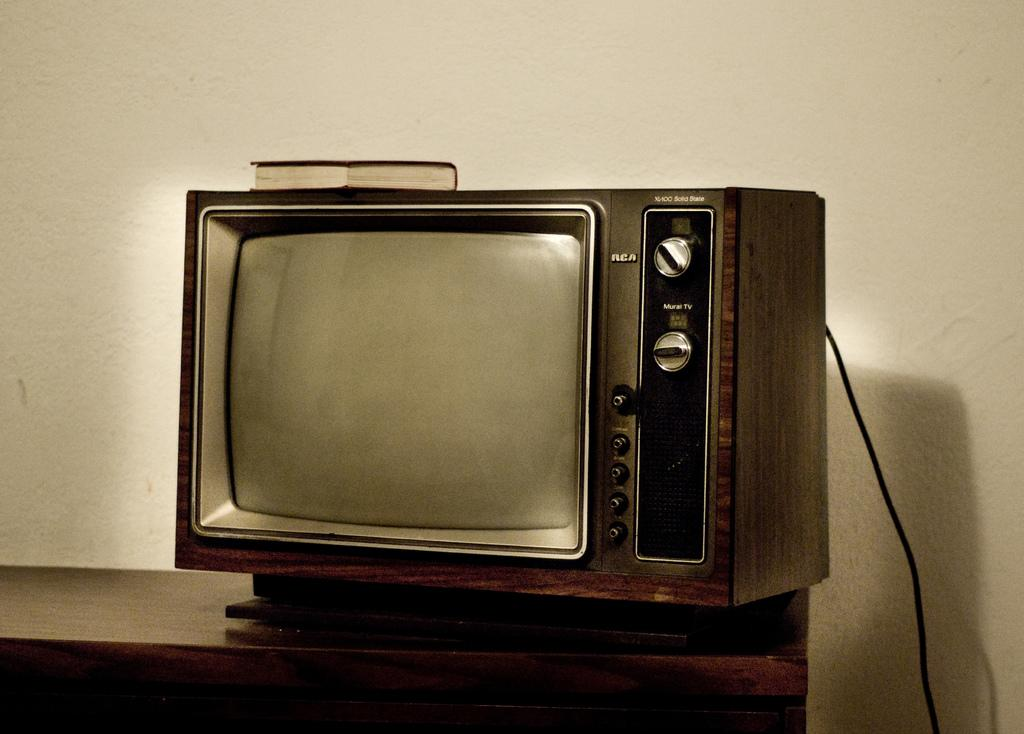<image>
Create a compact narrative representing the image presented. An old RCA television set has a book on top of it. 